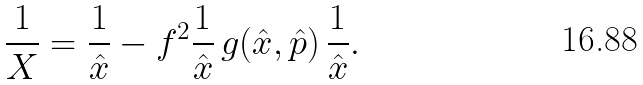Convert formula to latex. <formula><loc_0><loc_0><loc_500><loc_500>\frac { 1 } { X } = \frac { 1 } { \hat { x } } - f ^ { 2 } \frac { 1 } { \hat { x } } \, g ( \hat { x } , \hat { p } ) \, \frac { 1 } { \hat { x } } .</formula> 